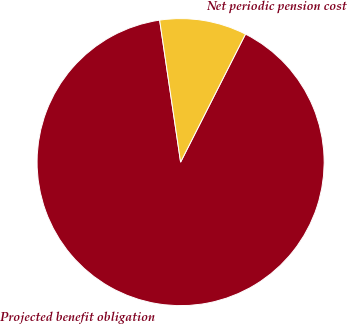<chart> <loc_0><loc_0><loc_500><loc_500><pie_chart><fcel>Projected benefit obligation<fcel>Net periodic pension cost<nl><fcel>90.2%<fcel>9.8%<nl></chart> 